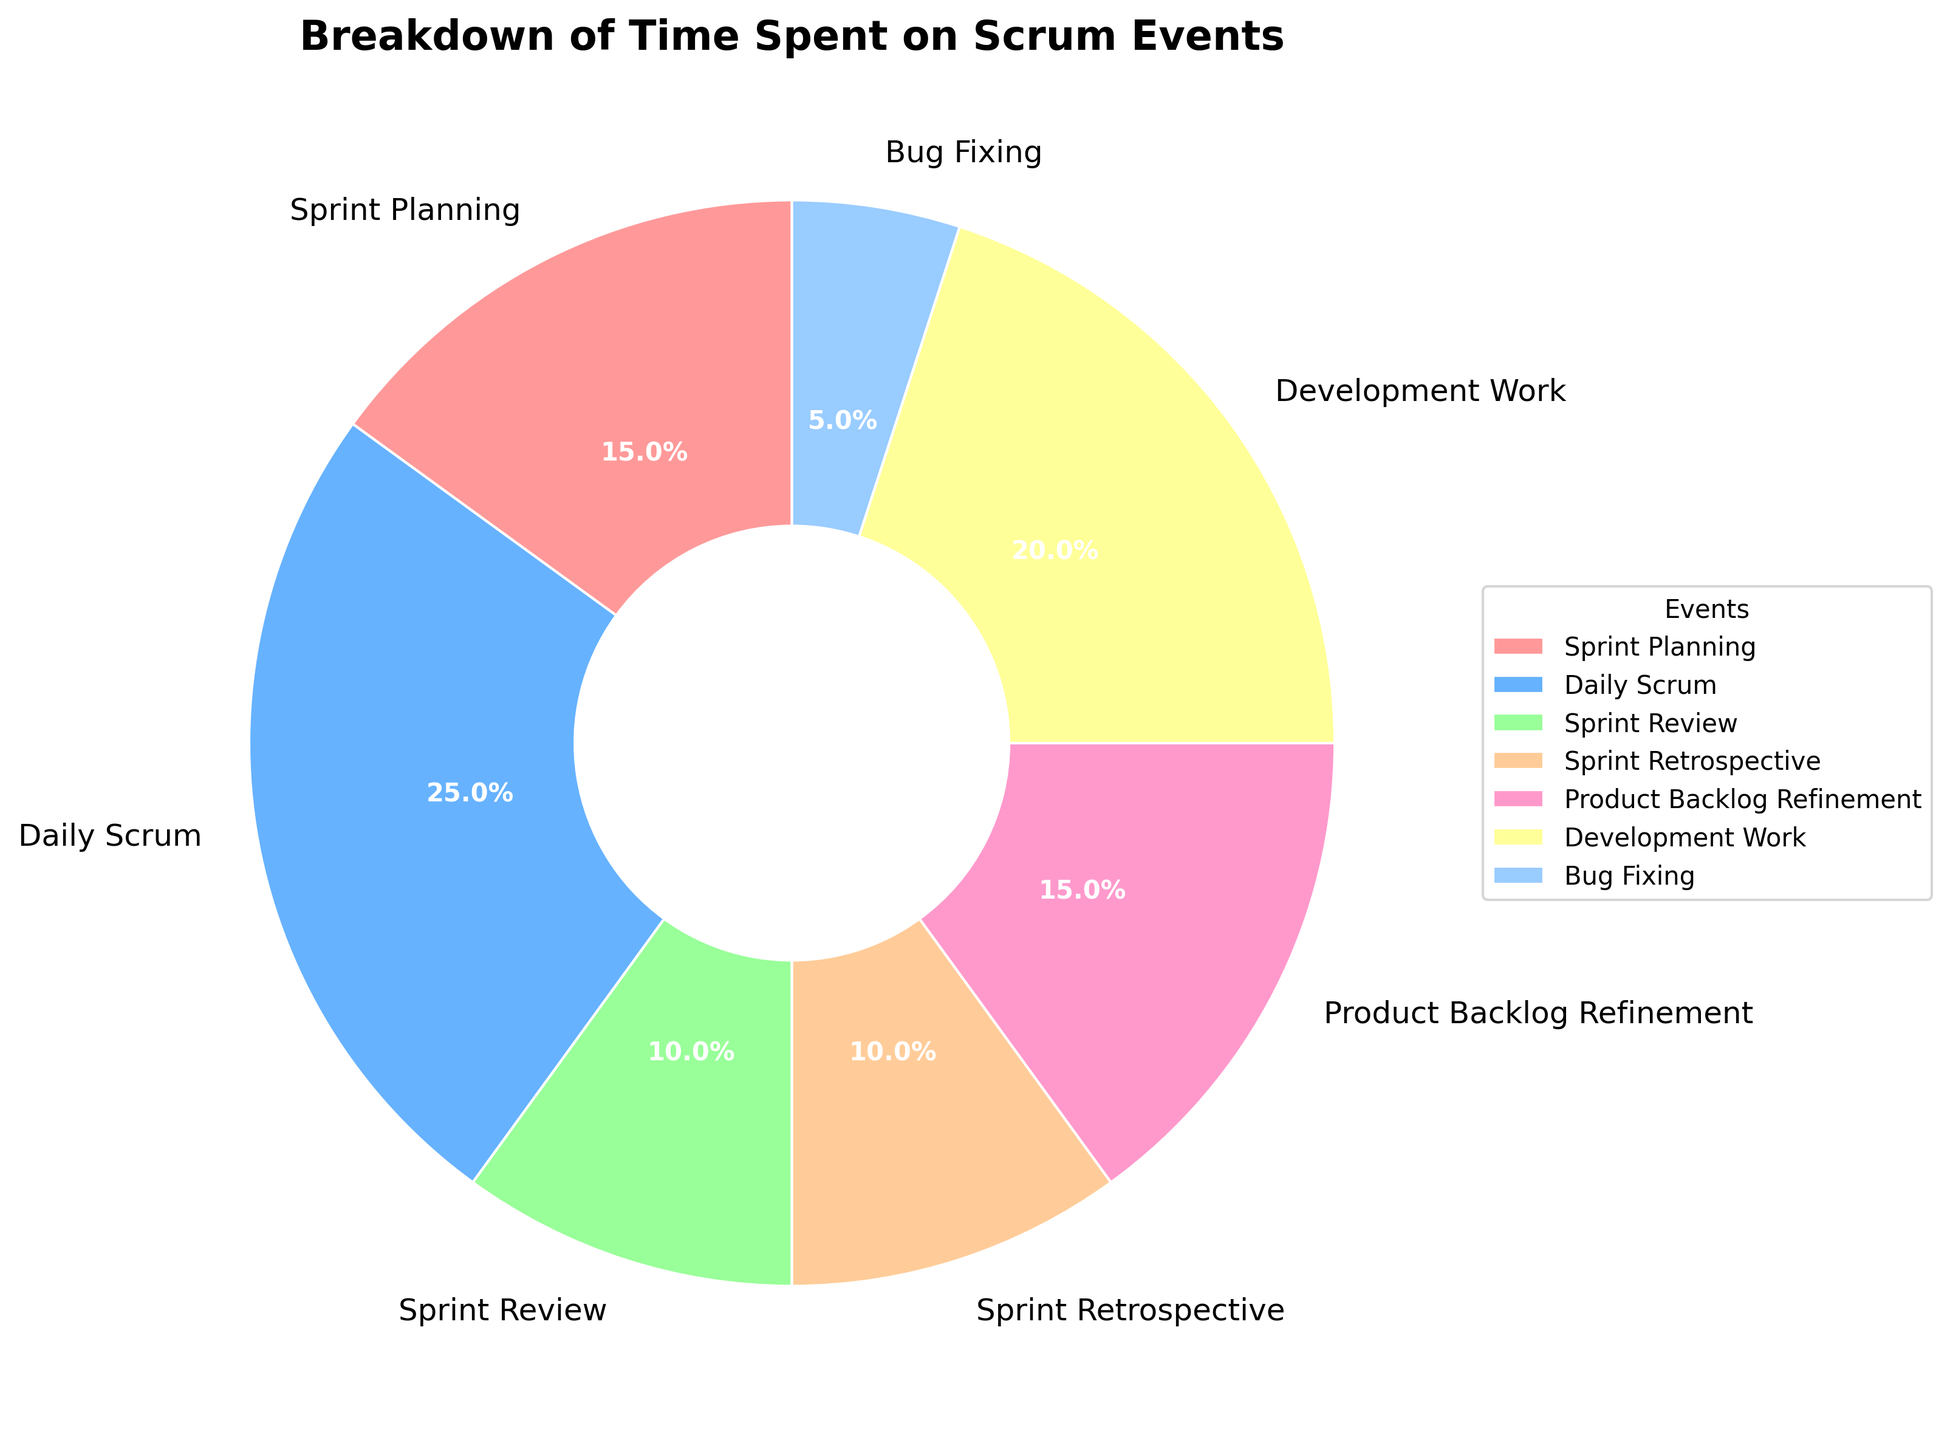What percentage of the total time is spent on Development Work and Bug Fixing combined? Add the percentage of Development Work (20%) and Bug Fixing (5%). So, 20% + 5% = 25%.
Answer: 25% Which Scrum event takes up the most time in a typical Sprint? Look for the event with the largest percentage in the pie chart. Daily Scrum has the highest percentage at 25%.
Answer: Daily Scrum How does the time spent on Sprint Planning compare to that spent on Sprint Review? Compare the percentages of Sprint Planning and Sprint Review. Sprint Planning is 15% while Sprint Review is 10%. So Sprint Planning takes up more time.
Answer: Sprint Planning takes up more time What is the total percentage of time spent on all Scrum events excluding Development Work and Bug Fixing? Sum the percentages of all listed Scrum events: Sprint Planning (15%), Daily Scrum (25%), Sprint Review (10%), Sprint Retrospective (10%), Product Backlog Refinement (15%). So, 15% + 25% + 10% + 10% + 15% = 75%.
Answer: 75% What percentage of time is spent on Sprint Retrospective compared to Sprint Planning? Sprint Retrospective takes 10% and Sprint Planning takes 15% of the time. The ratio is 10% / 15%, which simplifies to about 0.67.
Answer: 0.67 Is the time spent on Daily Scrum greater than the combined time spent on Sprint Review and Sprint Retrospective? Daily Scrum takes 25%. Sprint Review is 10% and Sprint Retrospective is 10%. Combined, Sprint Review and Sprint Retrospective is 10% + 10% = 20%. Since 25% > 20%, Daily Scrum takes more time.
Answer: Yes What's the difference in the time spent on Product Backlog Refinement and Bug Fixing? Subtract the percentage of Bug Fixing (5%) from the percentage of Product Backlog Refinement (15%). So, 15% - 5% = 10%.
Answer: 10% What is the average time spent on Sprint Planning, Sprint Review, and Sprint Retrospective? Sum the percentages of Sprint Planning (15%), Sprint Review (10%), and Sprint Retrospective (10%). Then, divide by 3. So, (15% + 10% + 10%) / 3 = 35% / 3 ≈ 11.67%.
Answer: 11.67% Which event is represented by the wedge in light blue? The light blue color indicates the event labeled as Sprint Review in the pie chart.
Answer: Sprint Review 